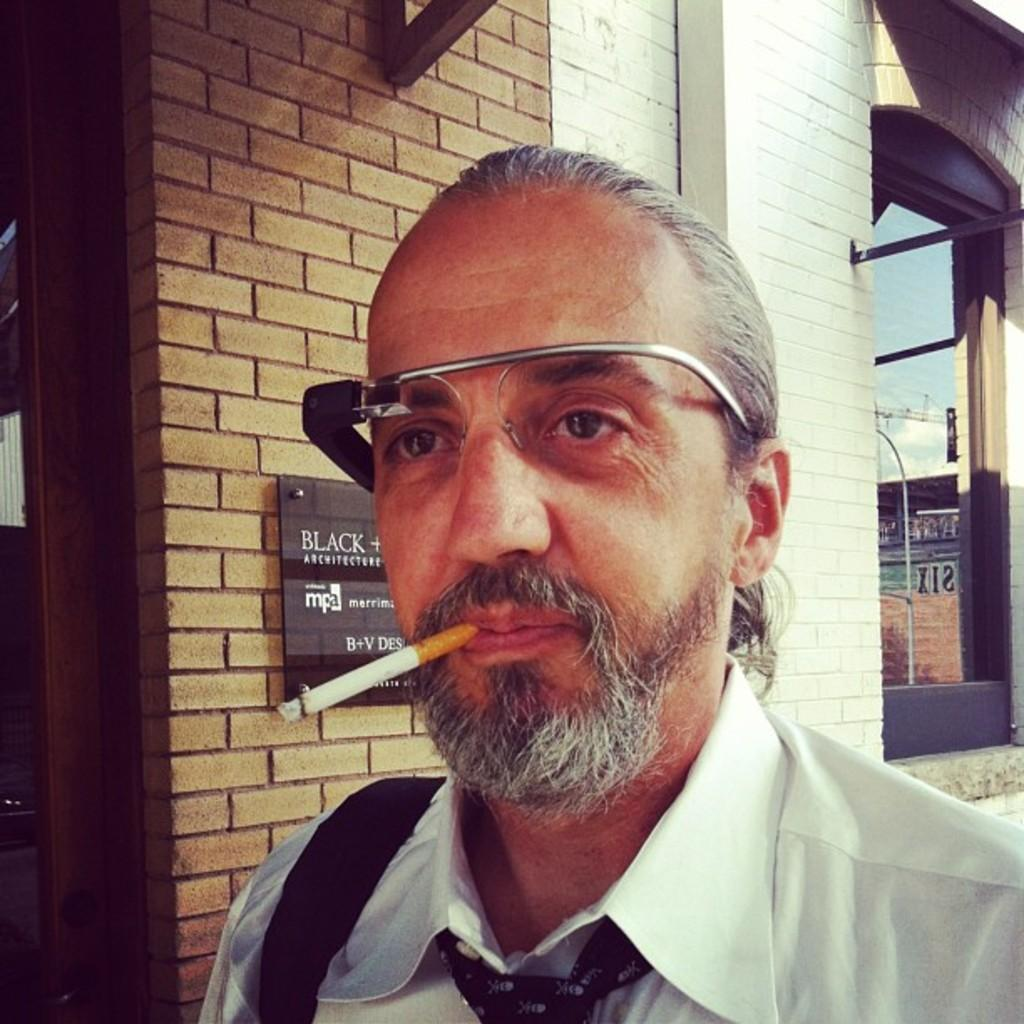Who is present in the image? There is a man in the image. What can be observed about the man's appearance? The man is wearing glasses. What activity is the man engaged in? The man is smoking a cigarette. What can be seen on the wall in the background of the image? There is a board on the wall in the background of the image. What type of structure is visible in the background of the image? There is a building visible in the background of the image. What type of ray is swimming in the water near the man in the image? There is no ray or water present in the image; it features a man smoking a cigarette with a board and a building in the background. What type of wine is the man holding in the image? There is no wine present in the image; the man is smoking a cigarette. 